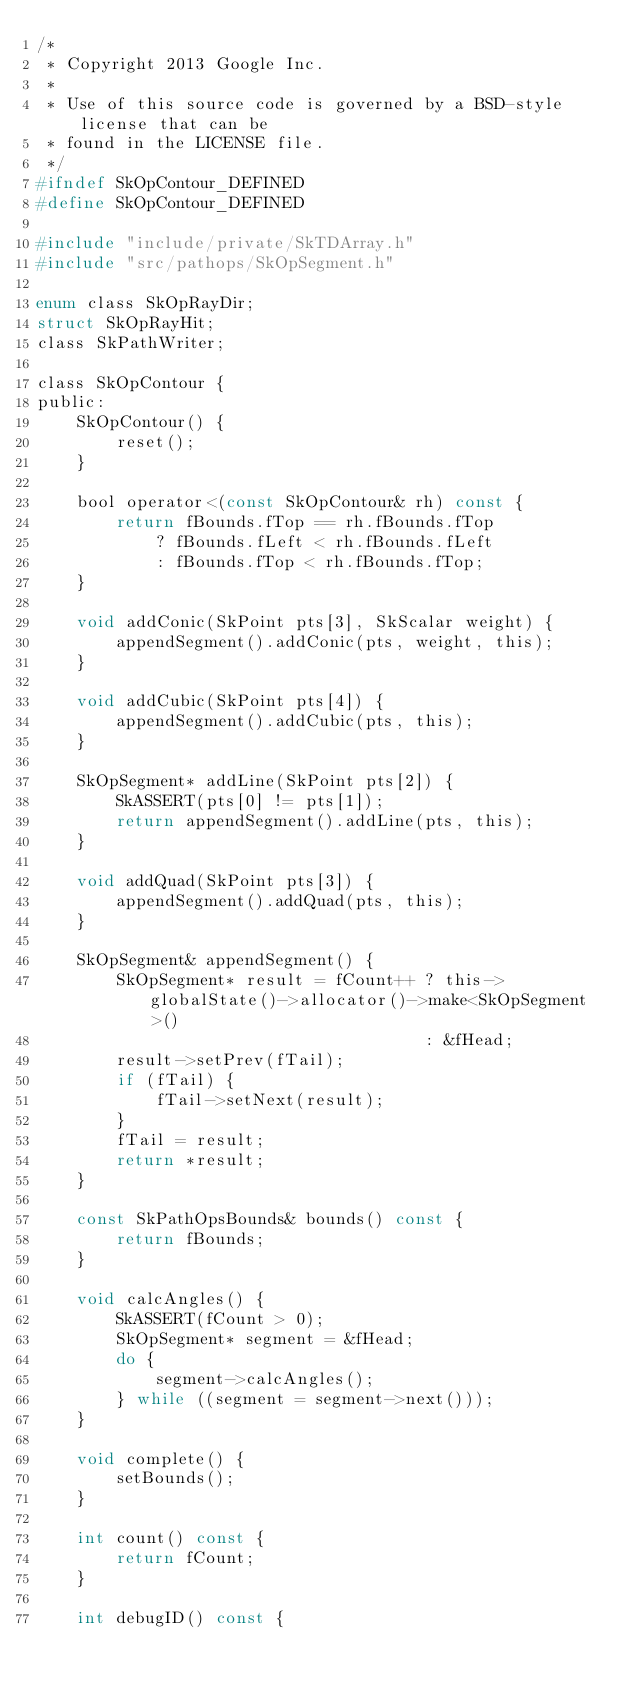Convert code to text. <code><loc_0><loc_0><loc_500><loc_500><_C_>/*
 * Copyright 2013 Google Inc.
 *
 * Use of this source code is governed by a BSD-style license that can be
 * found in the LICENSE file.
 */
#ifndef SkOpContour_DEFINED
#define SkOpContour_DEFINED

#include "include/private/SkTDArray.h"
#include "src/pathops/SkOpSegment.h"

enum class SkOpRayDir;
struct SkOpRayHit;
class SkPathWriter;

class SkOpContour {
public:
    SkOpContour() {
        reset();
    }

    bool operator<(const SkOpContour& rh) const {
        return fBounds.fTop == rh.fBounds.fTop
            ? fBounds.fLeft < rh.fBounds.fLeft
            : fBounds.fTop < rh.fBounds.fTop;
    }

    void addConic(SkPoint pts[3], SkScalar weight) {
        appendSegment().addConic(pts, weight, this);
    }

    void addCubic(SkPoint pts[4]) {
        appendSegment().addCubic(pts, this);
    }

    SkOpSegment* addLine(SkPoint pts[2]) {
        SkASSERT(pts[0] != pts[1]);
        return appendSegment().addLine(pts, this);
    }

    void addQuad(SkPoint pts[3]) {
        appendSegment().addQuad(pts, this);
    }

    SkOpSegment& appendSegment() {
        SkOpSegment* result = fCount++ ? this->globalState()->allocator()->make<SkOpSegment>()
                                       : &fHead;
        result->setPrev(fTail);
        if (fTail) {
            fTail->setNext(result);
        }
        fTail = result;
        return *result;
    }

    const SkPathOpsBounds& bounds() const {
        return fBounds;
    }

    void calcAngles() {
        SkASSERT(fCount > 0);
        SkOpSegment* segment = &fHead;
        do {
            segment->calcAngles();
        } while ((segment = segment->next()));
    }

    void complete() {
        setBounds();
    }

    int count() const {
        return fCount;
    }

    int debugID() const {</code> 